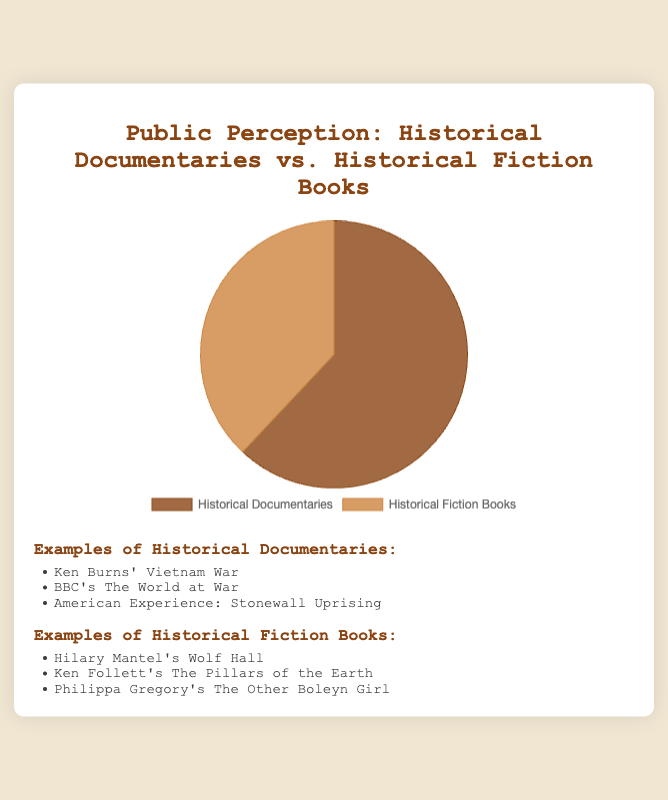What percentage of people prefer Historical Documentaries? The figure labels show that 62% of people prefer Historical Documentaries. This information can be deduced directly from the data points available in the pie chart.
Answer: 62% What is the ratio of the preference for Historical Documentaries to Historical Fiction Books? The value for Historical Documentaries is 62, and for Historical Fiction Books, it is 38. The ratio is thus 62:38, which can be simplified to 31:19.
Answer: 31:19 How much more popular are Historical Documentaries compared to Historical Fiction Books? The percentage for Historical Documentaries is 62%, and for Historical Fiction Books, it is 38%. The difference between them is 62% - 38% = 24%.
Answer: 24% What is the sum of the percentages for both categories? The sum of the values is 62% (Historical Documentaries) + 38% (Historical Fiction Books) = 100%.
Answer: 100% Which category is represented by the darker color in the pie chart? Observing the pie chart colors, Historical Documentaries are represented by a darker brown color while Historical Fiction Books are in a lighter brown shade.
Answer: Historical Documentaries If you had to show three examples from one of the categories, which category would include Ken Burns' Vietnam War? Ken Burns' Vietnam War is listed as an example under Historical Documentaries.
Answer: Historical Documentaries What is the average preference percentage between Historical Documentaries and Historical Fiction Books? The sum of the values is 62% + 38% = 100%. There are 2 data points, so the average is 100% / 2 = 50%.
Answer: 50% Is the preference for Historical Documentaries greater than 1.5 times the preference for Historical Fiction Books? Multiplying the value for Historical Fiction Books (38%) by 1.5 gives 38% * 1.5 = 57%. Since 62% > 57%, the preference for Historical Documentaries is indeed greater than 1.5 times that for Historical Fiction Books.
Answer: Yes Which category has the smaller segment in the pie chart? The percentage value for Historical Fiction Books is 38%, which is smaller than 62% for Historical Documentaries, hence Historical Fiction Books have the smaller segment.
Answer: Historical Fiction Books 